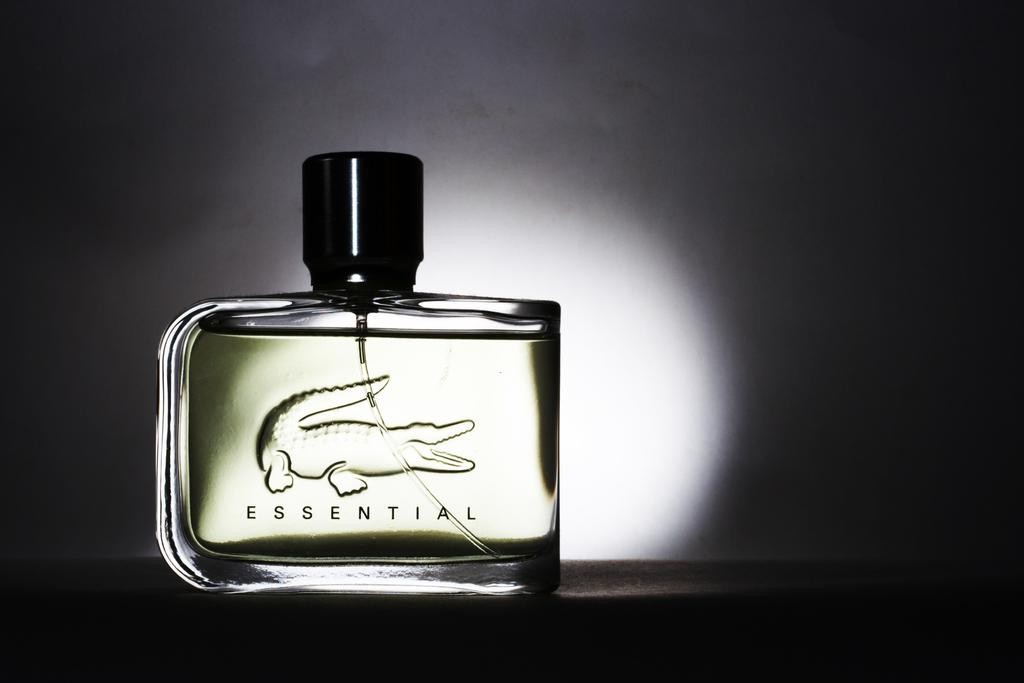<image>
Present a compact description of the photo's key features. Bottle of cologne named Essential with a crocodile on it. 